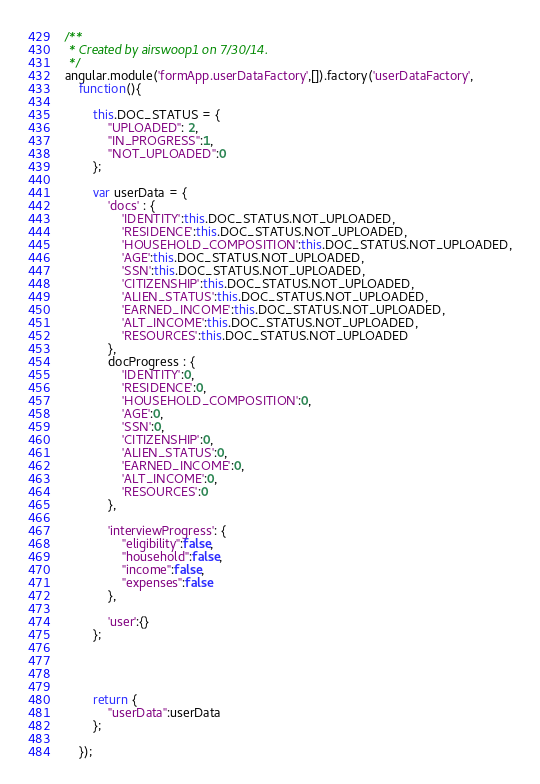<code> <loc_0><loc_0><loc_500><loc_500><_JavaScript_>/**
 * Created by airswoop1 on 7/30/14.
 */
angular.module('formApp.userDataFactory',[]).factory('userDataFactory',
	function(){

		this.DOC_STATUS = {
			"UPLOADED": 2,
			"IN_PROGRESS":1,
			"NOT_UPLOADED":0
		};

		var userData = {
			'docs' : {
				'IDENTITY':this.DOC_STATUS.NOT_UPLOADED,
				'RESIDENCE':this.DOC_STATUS.NOT_UPLOADED,
				'HOUSEHOLD_COMPOSITION':this.DOC_STATUS.NOT_UPLOADED,
				'AGE':this.DOC_STATUS.NOT_UPLOADED,
				'SSN':this.DOC_STATUS.NOT_UPLOADED,
				'CITIZENSHIP':this.DOC_STATUS.NOT_UPLOADED,
				'ALIEN_STATUS':this.DOC_STATUS.NOT_UPLOADED,
				'EARNED_INCOME':this.DOC_STATUS.NOT_UPLOADED,
				'ALT_INCOME':this.DOC_STATUS.NOT_UPLOADED,
				'RESOURCES':this.DOC_STATUS.NOT_UPLOADED
			},
			docProgress : {
				'IDENTITY':0,
				'RESIDENCE':0,
				'HOUSEHOLD_COMPOSITION':0,
				'AGE':0,
				'SSN':0,
				'CITIZENSHIP':0,
				'ALIEN_STATUS':0,
				'EARNED_INCOME':0,
				'ALT_INCOME':0,
				'RESOURCES':0
			},

			'interviewProgress': {
				"eligibility":false,
				"household":false,
				"income":false,
				"expenses":false
			},

			'user':{}
		};




		return {
			"userData":userData
		};

	});</code> 